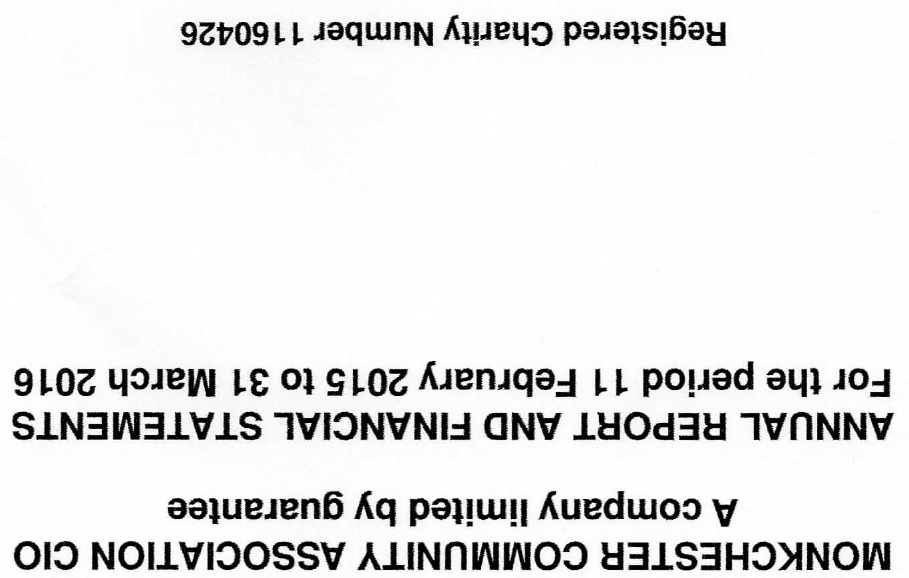What is the value for the charity_number?
Answer the question using a single word or phrase. 1160426 